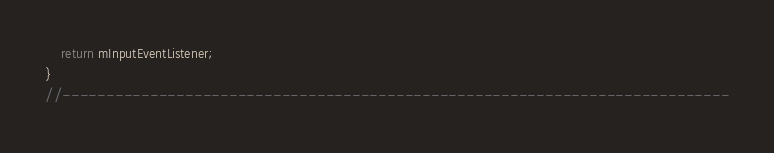<code> <loc_0><loc_0><loc_500><loc_500><_C++_>	return mInputEventListener;
}
//----------------------------------------------------------------------------</code> 